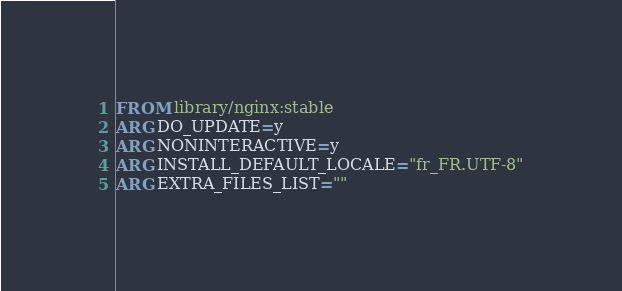<code> <loc_0><loc_0><loc_500><loc_500><_Dockerfile_>FROM library/nginx:stable
ARG DO_UPDATE=y
ARG NONINTERACTIVE=y
ARG INSTALL_DEFAULT_LOCALE="fr_FR.UTF-8"
ARG EXTRA_FILES_LIST=""</code> 